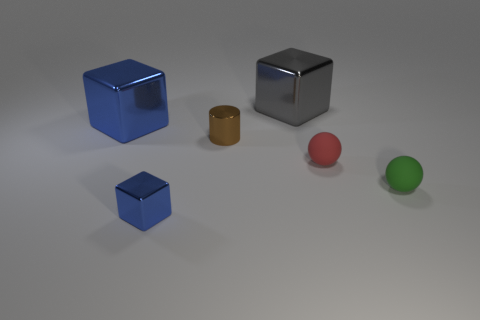The cylinder has what color?
Offer a terse response. Brown. Are there any other things that are the same shape as the tiny brown thing?
Keep it short and to the point. No. The other large shiny thing that is the same shape as the big gray object is what color?
Make the answer very short. Blue. Is the shape of the small brown thing the same as the tiny green rubber thing?
Provide a succinct answer. No. How many balls are either small brown metal things or tiny metallic things?
Provide a short and direct response. 0. What is the color of the other small thing that is made of the same material as the red thing?
Provide a succinct answer. Green. Do the blue metal thing that is in front of the green thing and the small green object have the same size?
Offer a very short reply. Yes. Does the brown cylinder have the same material as the blue cube that is left of the small blue metal block?
Give a very brief answer. Yes. There is a big metallic cube in front of the big gray metallic object; what color is it?
Make the answer very short. Blue. There is a metal thing behind the big blue metal cube; are there any large metal cubes to the left of it?
Make the answer very short. Yes. 